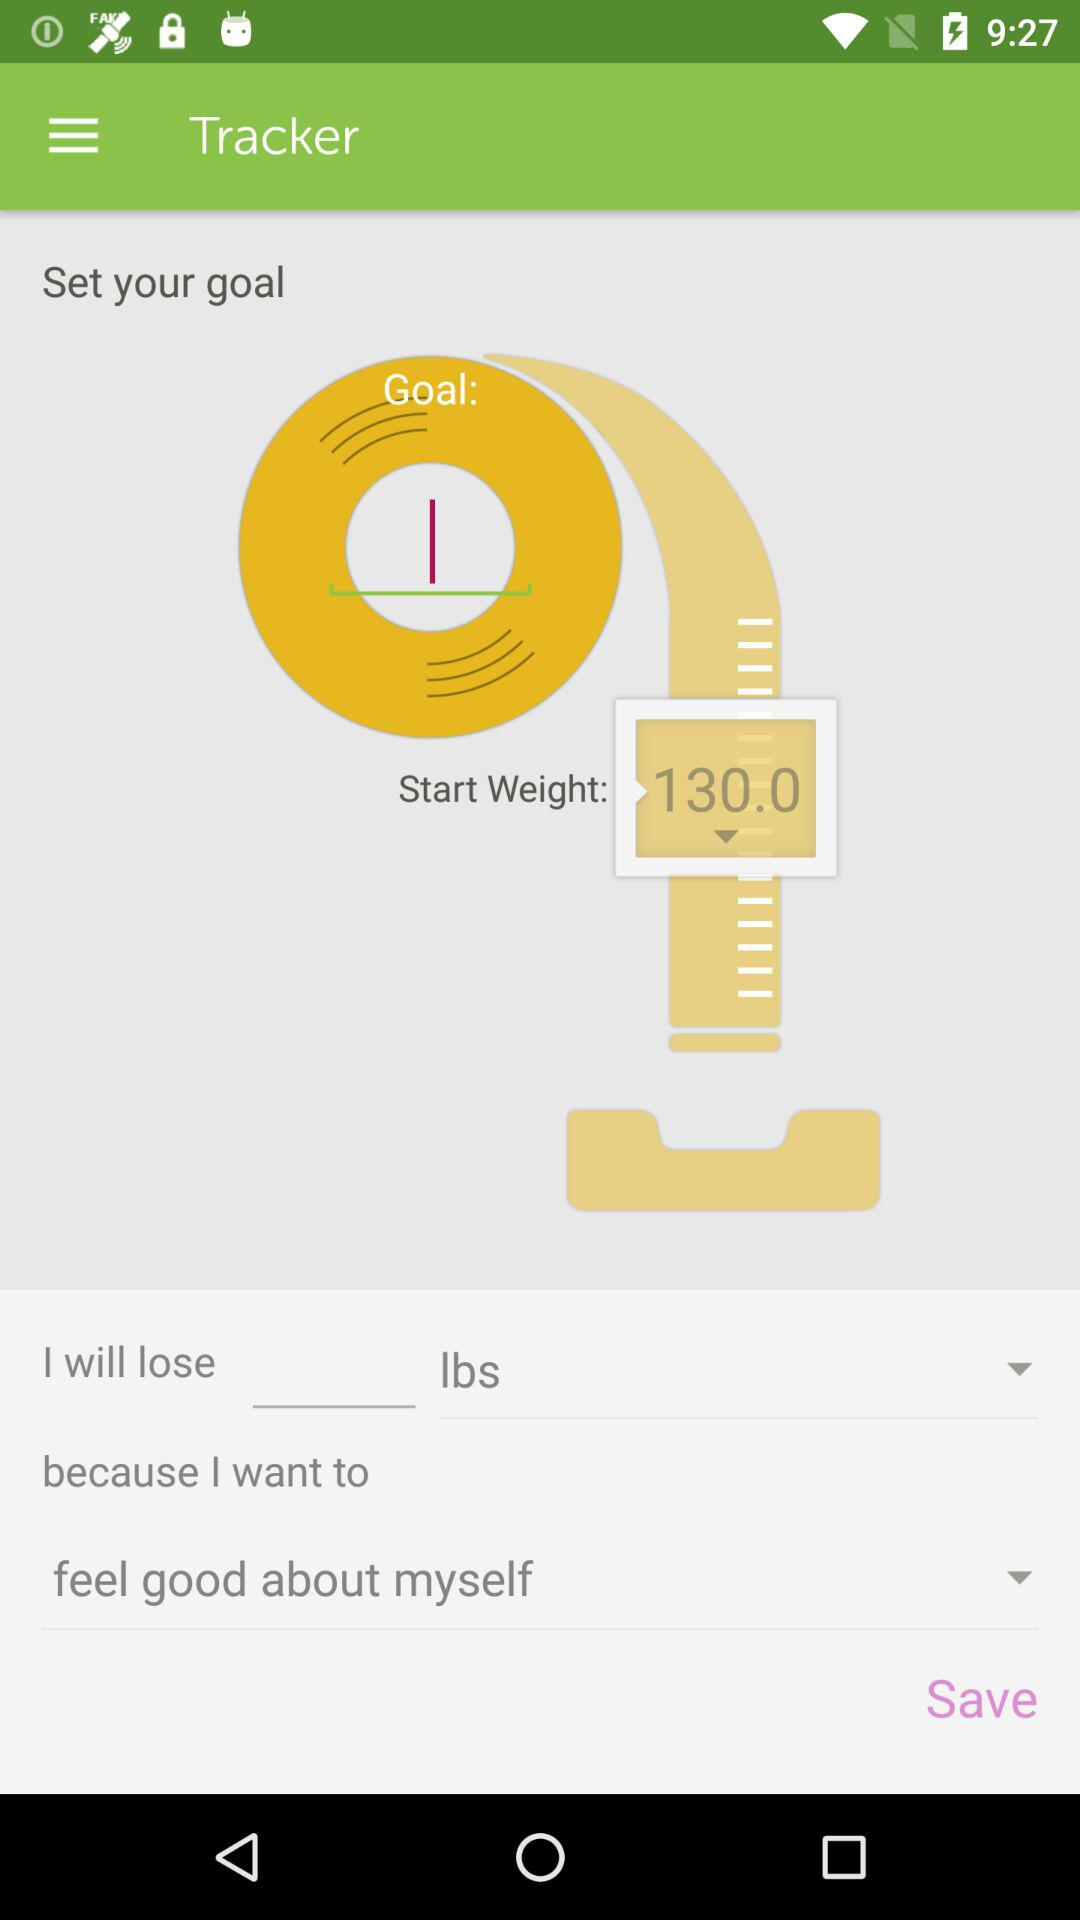What's the number of the "Start Weight"? Th number of the "Start Weight" is 130. 